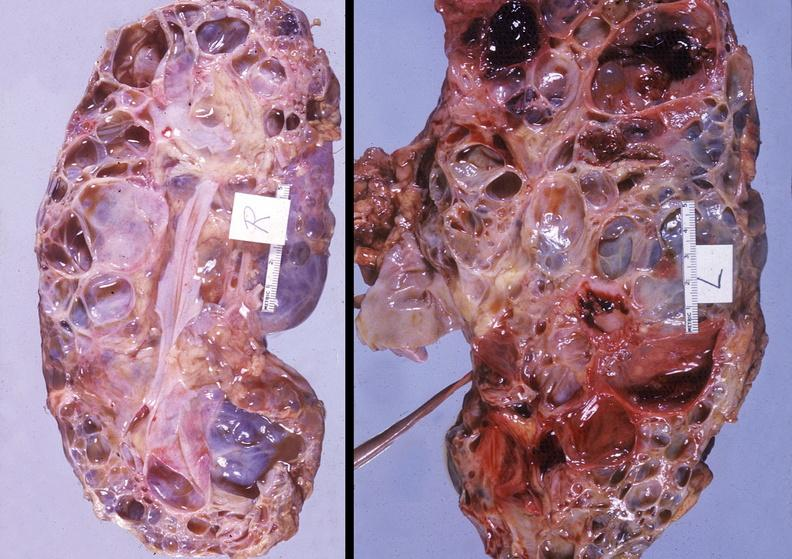does this image show kidney, polycystic disease?
Answer the question using a single word or phrase. Yes 